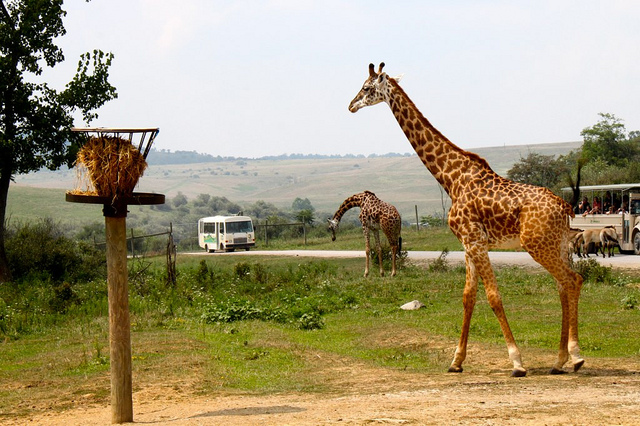Can you describe the type of vehicle seen on the right and its purpose in this setting? The vehicle on the right appears to be a safari jeep or tour bus, designed for wildlife viewing. Its open sides allow passengers to observe and photograph animals closely and safely, indicating its purpose is to facilitate wildlife tours within a park or reserve. 